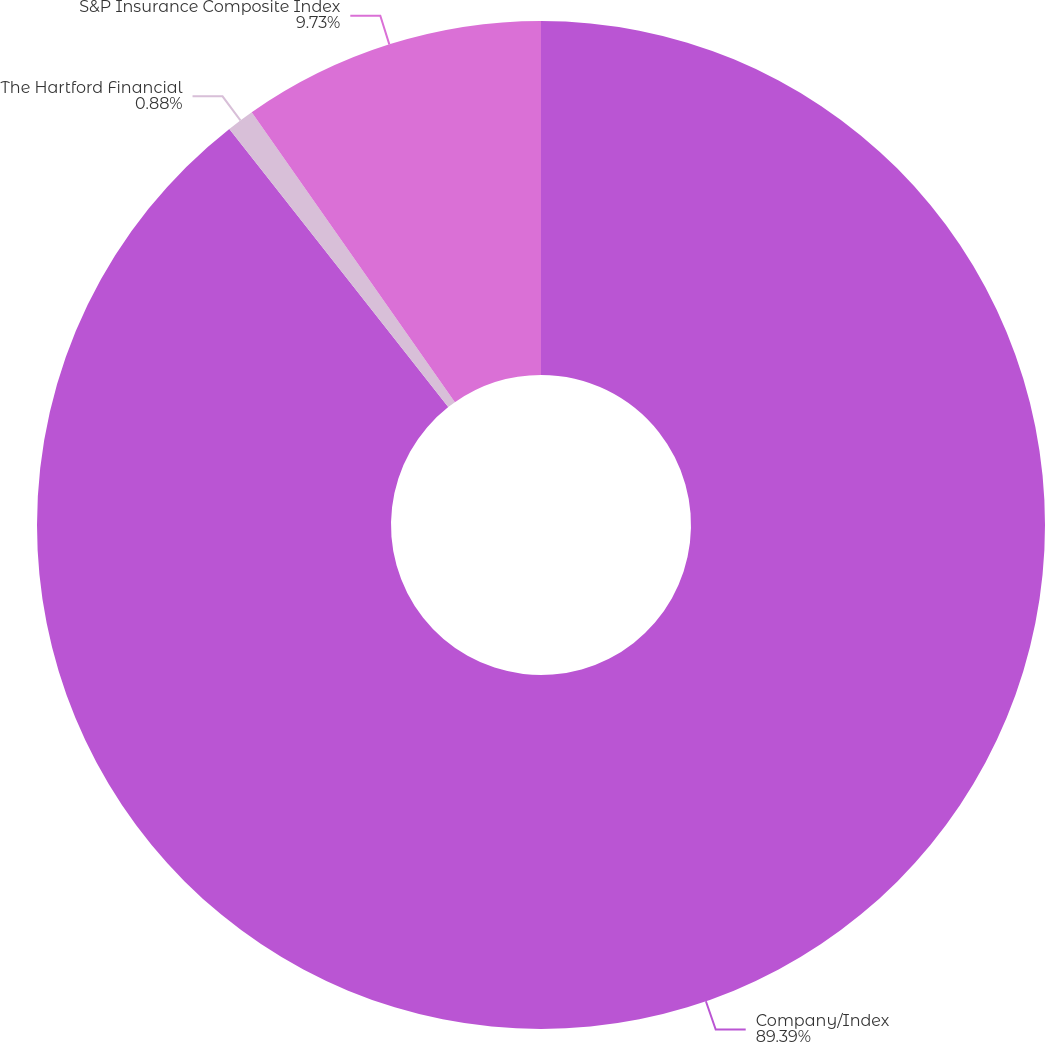Convert chart to OTSL. <chart><loc_0><loc_0><loc_500><loc_500><pie_chart><fcel>Company/Index<fcel>The Hartford Financial<fcel>S&P Insurance Composite Index<nl><fcel>89.39%<fcel>0.88%<fcel>9.73%<nl></chart> 